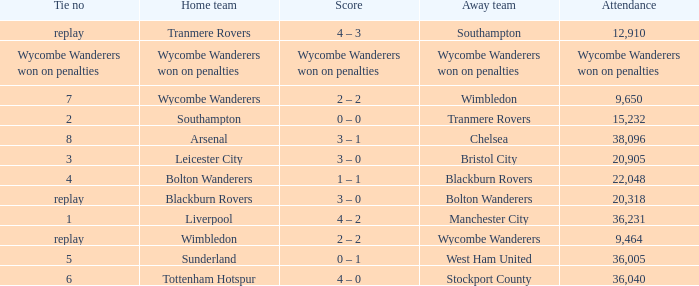What was the score of having a tie of 1? 4 – 2. 